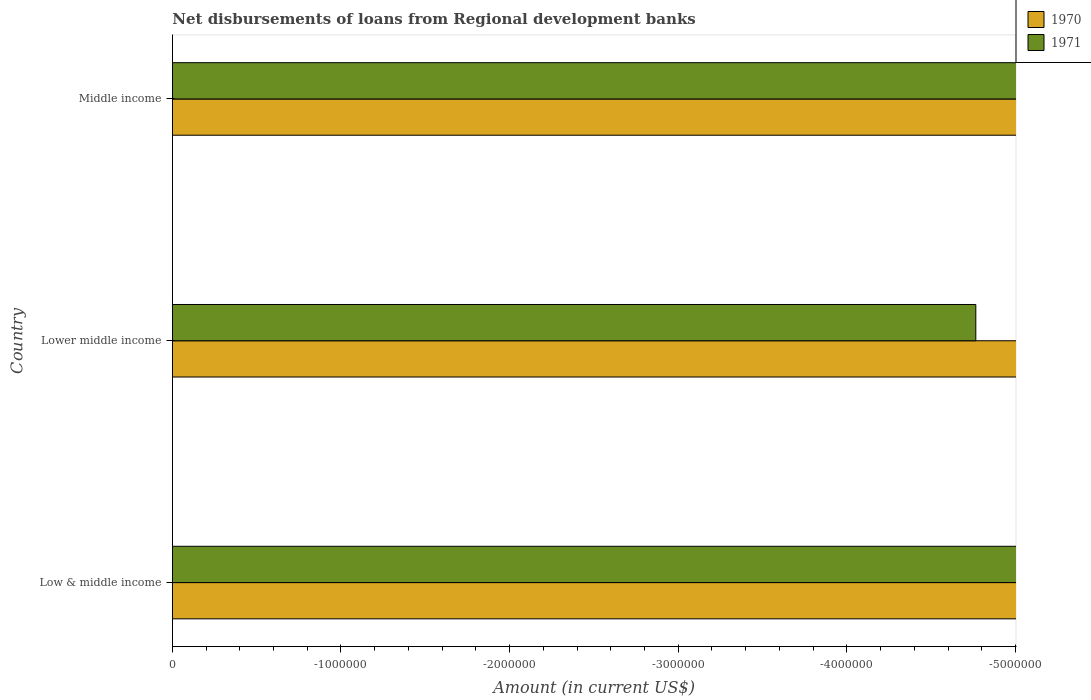How many different coloured bars are there?
Offer a very short reply. 0. Are the number of bars on each tick of the Y-axis equal?
Provide a succinct answer. Yes. How many bars are there on the 3rd tick from the top?
Keep it short and to the point. 0. How many bars are there on the 1st tick from the bottom?
Give a very brief answer. 0. In how many cases, is the number of bars for a given country not equal to the number of legend labels?
Make the answer very short. 3. What is the average amount of disbursements of loans from regional development banks in 1970 per country?
Ensure brevity in your answer.  0. In how many countries, is the amount of disbursements of loans from regional development banks in 1970 greater than -1200000 US$?
Your answer should be very brief. 0. In how many countries, is the amount of disbursements of loans from regional development banks in 1971 greater than the average amount of disbursements of loans from regional development banks in 1971 taken over all countries?
Keep it short and to the point. 0. How many bars are there?
Provide a succinct answer. 0. Are all the bars in the graph horizontal?
Your answer should be compact. Yes. How many countries are there in the graph?
Your answer should be very brief. 3. What is the difference between two consecutive major ticks on the X-axis?
Your response must be concise. 1.00e+06. Where does the legend appear in the graph?
Provide a short and direct response. Top right. How many legend labels are there?
Your answer should be compact. 2. What is the title of the graph?
Your response must be concise. Net disbursements of loans from Regional development banks. What is the Amount (in current US$) in 1971 in Low & middle income?
Keep it short and to the point. 0. What is the Amount (in current US$) in 1971 in Lower middle income?
Keep it short and to the point. 0. What is the Amount (in current US$) of 1970 in Middle income?
Your answer should be compact. 0. What is the Amount (in current US$) in 1971 in Middle income?
Offer a very short reply. 0. 